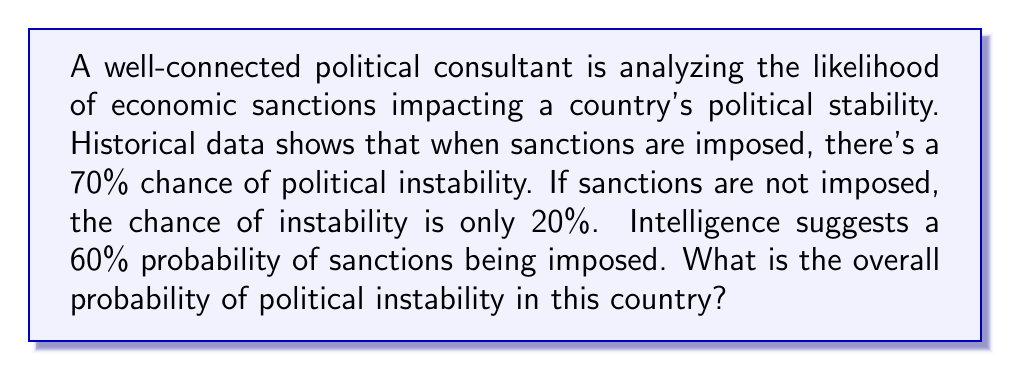Can you solve this math problem? Let's approach this step-by-step using the law of total probability:

1) Define events:
   S: Sanctions are imposed
   I: Political instability occurs

2) Given probabilities:
   P(S) = 0.60 (probability of sanctions)
   P(I|S) = 0.70 (probability of instability given sanctions)
   P(I|not S) = 0.20 (probability of instability without sanctions)

3) We want to find P(I), the overall probability of instability.

4) Using the law of total probability:
   $$P(I) = P(I|S) \cdot P(S) + P(I|\text{not }S) \cdot P(\text{not }S)$$

5) We know P(S) = 0.60, so P(not S) = 1 - 0.60 = 0.40

6) Substituting the values:
   $$P(I) = 0.70 \cdot 0.60 + 0.20 \cdot 0.40$$

7) Calculating:
   $$P(I) = 0.42 + 0.08 = 0.50$$

Thus, the overall probability of political instability is 0.50 or 50%.
Answer: 0.50 